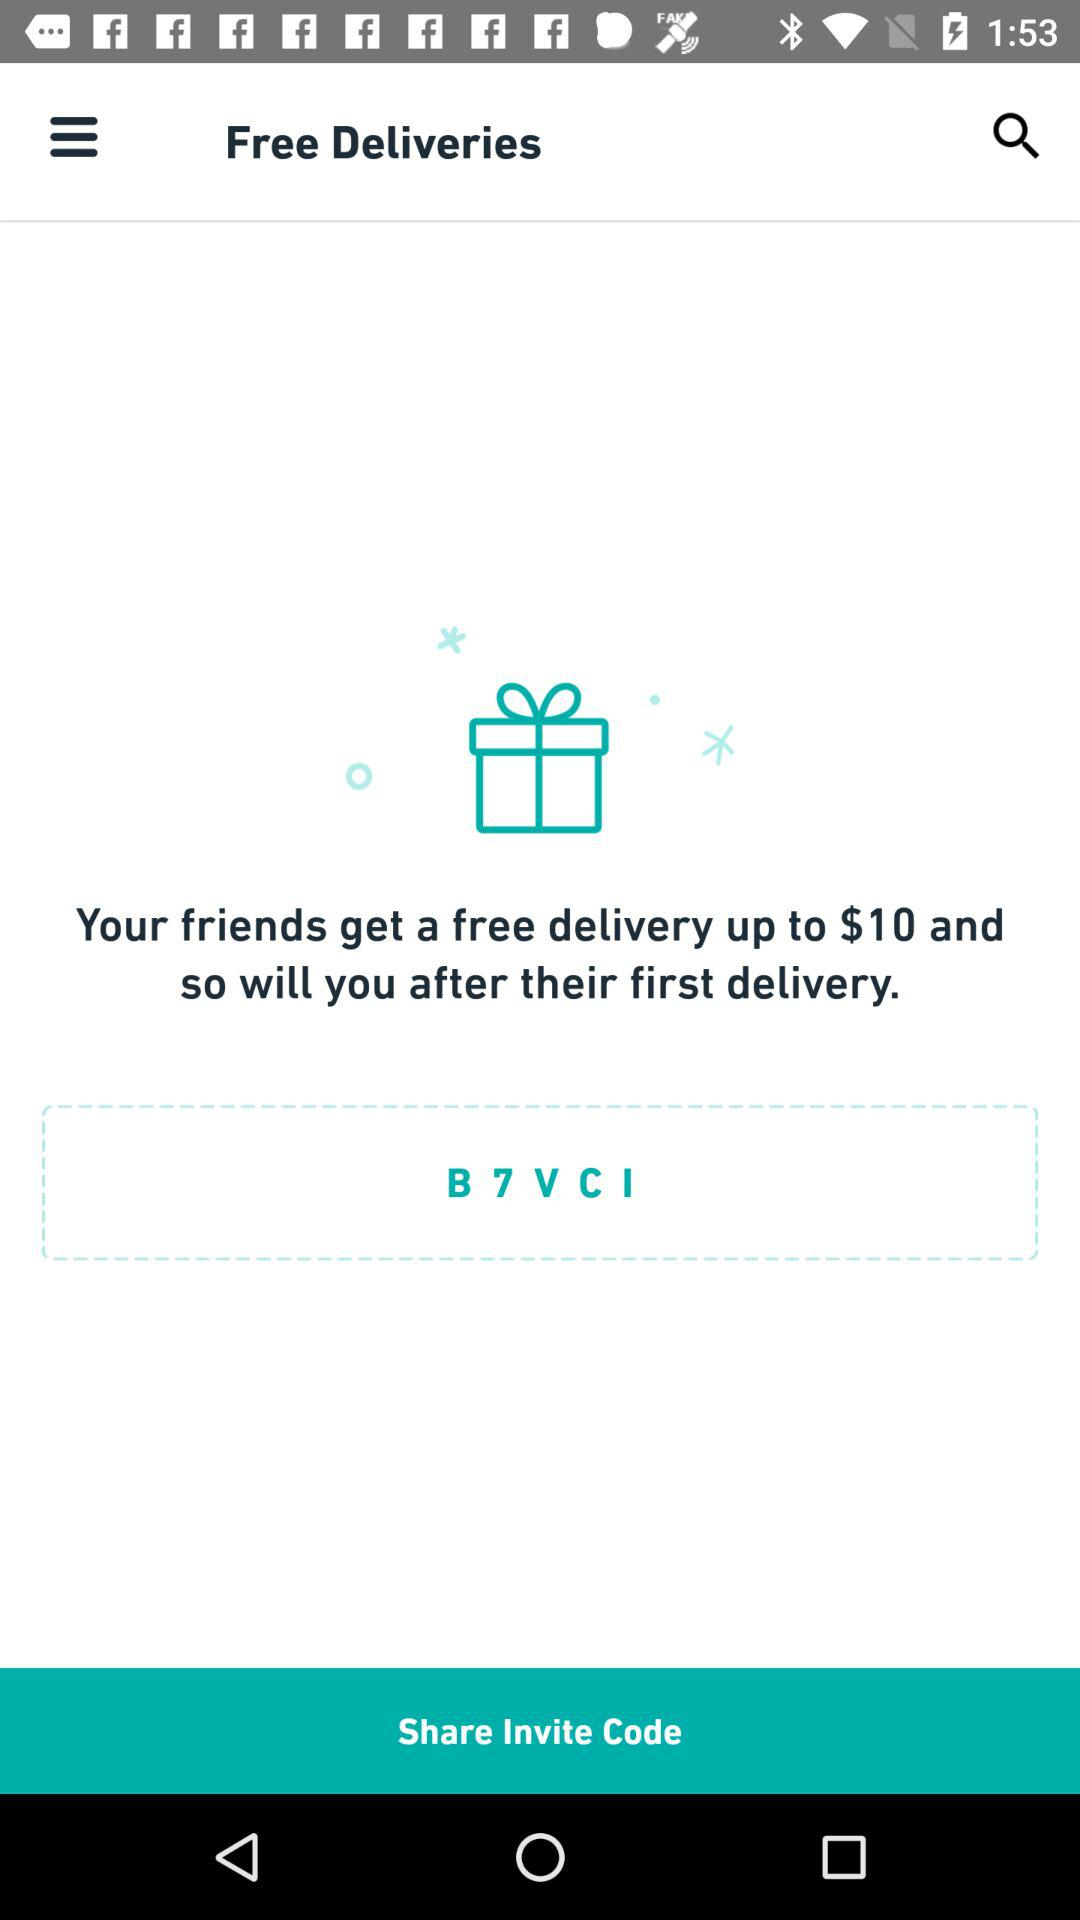What is the invite code? The invite code is "B7VCI". 